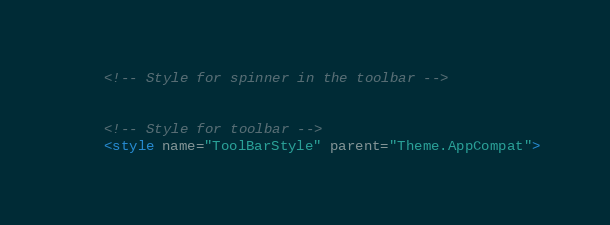<code> <loc_0><loc_0><loc_500><loc_500><_XML_>
    <!-- Style for spinner in the toolbar -->


    <!-- Style for toolbar -->
    <style name="ToolBarStyle" parent="Theme.AppCompat"></code> 